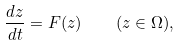<formula> <loc_0><loc_0><loc_500><loc_500>\frac { d { z } } { d t } = F ( { z } ) \quad ( { z } \in \Omega ) ,</formula> 